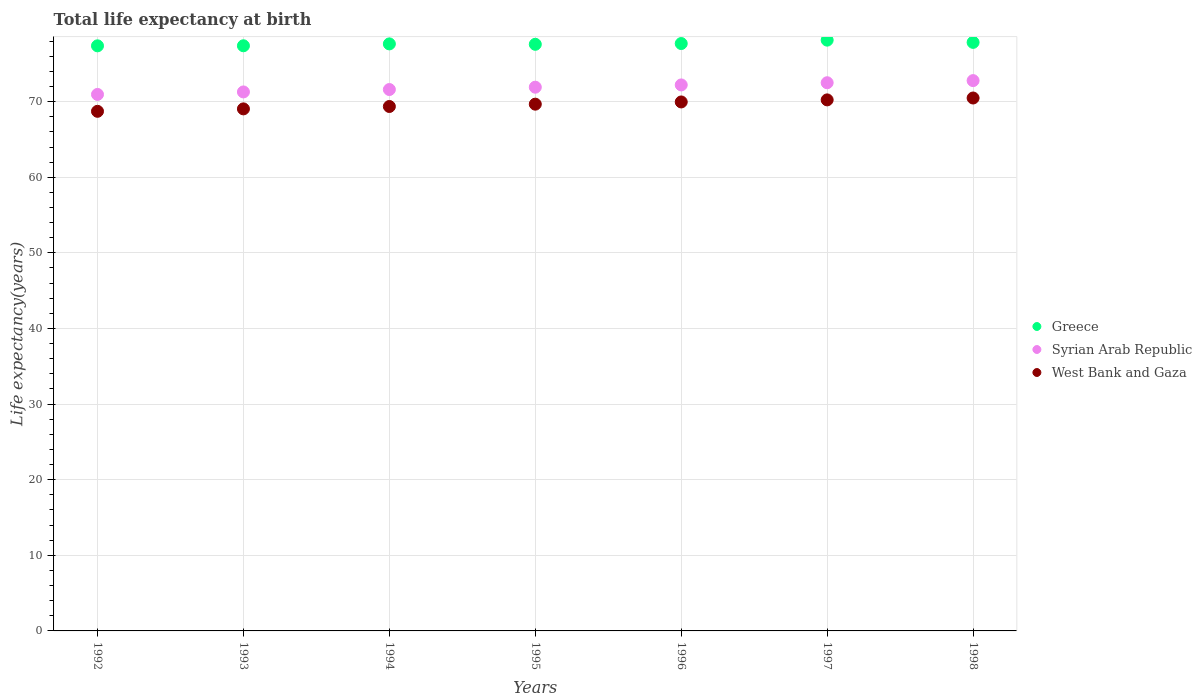How many different coloured dotlines are there?
Ensure brevity in your answer.  3. What is the life expectancy at birth in in West Bank and Gaza in 1993?
Your answer should be compact. 69.04. Across all years, what is the maximum life expectancy at birth in in West Bank and Gaza?
Your response must be concise. 70.48. Across all years, what is the minimum life expectancy at birth in in West Bank and Gaza?
Ensure brevity in your answer.  68.72. What is the total life expectancy at birth in in Syrian Arab Republic in the graph?
Provide a succinct answer. 503.25. What is the difference between the life expectancy at birth in in West Bank and Gaza in 1992 and that in 1993?
Keep it short and to the point. -0.32. What is the difference between the life expectancy at birth in in West Bank and Gaza in 1994 and the life expectancy at birth in in Syrian Arab Republic in 1997?
Your answer should be very brief. -3.14. What is the average life expectancy at birth in in West Bank and Gaza per year?
Offer a terse response. 69.64. In the year 1997, what is the difference between the life expectancy at birth in in West Bank and Gaza and life expectancy at birth in in Syrian Arab Republic?
Ensure brevity in your answer.  -2.27. In how many years, is the life expectancy at birth in in Greece greater than 20 years?
Your response must be concise. 7. What is the ratio of the life expectancy at birth in in Syrian Arab Republic in 1996 to that in 1997?
Provide a short and direct response. 1. What is the difference between the highest and the second highest life expectancy at birth in in Syrian Arab Republic?
Offer a terse response. 0.28. What is the difference between the highest and the lowest life expectancy at birth in in Greece?
Your answer should be very brief. 0.75. In how many years, is the life expectancy at birth in in West Bank and Gaza greater than the average life expectancy at birth in in West Bank and Gaza taken over all years?
Your answer should be very brief. 4. Does the life expectancy at birth in in Syrian Arab Republic monotonically increase over the years?
Keep it short and to the point. Yes. Is the life expectancy at birth in in Greece strictly greater than the life expectancy at birth in in Syrian Arab Republic over the years?
Provide a short and direct response. Yes. How many dotlines are there?
Your response must be concise. 3. Does the graph contain any zero values?
Offer a terse response. No. Does the graph contain grids?
Ensure brevity in your answer.  Yes. How many legend labels are there?
Provide a short and direct response. 3. What is the title of the graph?
Keep it short and to the point. Total life expectancy at birth. Does "Mozambique" appear as one of the legend labels in the graph?
Offer a very short reply. No. What is the label or title of the X-axis?
Offer a very short reply. Years. What is the label or title of the Y-axis?
Keep it short and to the point. Life expectancy(years). What is the Life expectancy(years) of Greece in 1992?
Your answer should be compact. 77.38. What is the Life expectancy(years) in Syrian Arab Republic in 1992?
Give a very brief answer. 70.96. What is the Life expectancy(years) in West Bank and Gaza in 1992?
Your response must be concise. 68.72. What is the Life expectancy(years) in Greece in 1993?
Keep it short and to the point. 77.39. What is the Life expectancy(years) in Syrian Arab Republic in 1993?
Your answer should be very brief. 71.29. What is the Life expectancy(years) in West Bank and Gaza in 1993?
Give a very brief answer. 69.04. What is the Life expectancy(years) of Greece in 1994?
Offer a terse response. 77.64. What is the Life expectancy(years) of Syrian Arab Republic in 1994?
Your response must be concise. 71.6. What is the Life expectancy(years) of West Bank and Gaza in 1994?
Offer a terse response. 69.36. What is the Life expectancy(years) in Greece in 1995?
Your answer should be very brief. 77.59. What is the Life expectancy(years) in Syrian Arab Republic in 1995?
Make the answer very short. 71.91. What is the Life expectancy(years) of West Bank and Gaza in 1995?
Give a very brief answer. 69.67. What is the Life expectancy(years) in Greece in 1996?
Your response must be concise. 77.69. What is the Life expectancy(years) in Syrian Arab Republic in 1996?
Give a very brief answer. 72.21. What is the Life expectancy(years) of West Bank and Gaza in 1996?
Your response must be concise. 69.96. What is the Life expectancy(years) of Greece in 1997?
Ensure brevity in your answer.  78.14. What is the Life expectancy(years) of Syrian Arab Republic in 1997?
Your answer should be compact. 72.5. What is the Life expectancy(years) of West Bank and Gaza in 1997?
Provide a succinct answer. 70.23. What is the Life expectancy(years) of Greece in 1998?
Your answer should be very brief. 77.84. What is the Life expectancy(years) in Syrian Arab Republic in 1998?
Your response must be concise. 72.78. What is the Life expectancy(years) of West Bank and Gaza in 1998?
Your response must be concise. 70.48. Across all years, what is the maximum Life expectancy(years) of Greece?
Your response must be concise. 78.14. Across all years, what is the maximum Life expectancy(years) of Syrian Arab Republic?
Provide a short and direct response. 72.78. Across all years, what is the maximum Life expectancy(years) of West Bank and Gaza?
Your answer should be compact. 70.48. Across all years, what is the minimum Life expectancy(years) in Greece?
Your response must be concise. 77.38. Across all years, what is the minimum Life expectancy(years) of Syrian Arab Republic?
Keep it short and to the point. 70.96. Across all years, what is the minimum Life expectancy(years) of West Bank and Gaza?
Your response must be concise. 68.72. What is the total Life expectancy(years) in Greece in the graph?
Ensure brevity in your answer.  543.66. What is the total Life expectancy(years) of Syrian Arab Republic in the graph?
Make the answer very short. 503.25. What is the total Life expectancy(years) of West Bank and Gaza in the graph?
Your answer should be very brief. 487.47. What is the difference between the Life expectancy(years) in Greece in 1992 and that in 1993?
Ensure brevity in your answer.  -0.01. What is the difference between the Life expectancy(years) of Syrian Arab Republic in 1992 and that in 1993?
Make the answer very short. -0.33. What is the difference between the Life expectancy(years) in West Bank and Gaza in 1992 and that in 1993?
Give a very brief answer. -0.32. What is the difference between the Life expectancy(years) in Greece in 1992 and that in 1994?
Keep it short and to the point. -0.26. What is the difference between the Life expectancy(years) of Syrian Arab Republic in 1992 and that in 1994?
Your response must be concise. -0.65. What is the difference between the Life expectancy(years) of West Bank and Gaza in 1992 and that in 1994?
Offer a very short reply. -0.64. What is the difference between the Life expectancy(years) in Greece in 1992 and that in 1995?
Ensure brevity in your answer.  -0.2. What is the difference between the Life expectancy(years) of Syrian Arab Republic in 1992 and that in 1995?
Give a very brief answer. -0.96. What is the difference between the Life expectancy(years) in West Bank and Gaza in 1992 and that in 1995?
Make the answer very short. -0.94. What is the difference between the Life expectancy(years) in Greece in 1992 and that in 1996?
Your response must be concise. -0.3. What is the difference between the Life expectancy(years) in Syrian Arab Republic in 1992 and that in 1996?
Your answer should be very brief. -1.26. What is the difference between the Life expectancy(years) in West Bank and Gaza in 1992 and that in 1996?
Offer a terse response. -1.24. What is the difference between the Life expectancy(years) in Greece in 1992 and that in 1997?
Keep it short and to the point. -0.75. What is the difference between the Life expectancy(years) in Syrian Arab Republic in 1992 and that in 1997?
Offer a terse response. -1.55. What is the difference between the Life expectancy(years) of West Bank and Gaza in 1992 and that in 1997?
Offer a terse response. -1.51. What is the difference between the Life expectancy(years) in Greece in 1992 and that in 1998?
Provide a short and direct response. -0.46. What is the difference between the Life expectancy(years) of Syrian Arab Republic in 1992 and that in 1998?
Ensure brevity in your answer.  -1.83. What is the difference between the Life expectancy(years) in West Bank and Gaza in 1992 and that in 1998?
Provide a succinct answer. -1.76. What is the difference between the Life expectancy(years) of Greece in 1993 and that in 1994?
Provide a short and direct response. -0.25. What is the difference between the Life expectancy(years) of Syrian Arab Republic in 1993 and that in 1994?
Ensure brevity in your answer.  -0.32. What is the difference between the Life expectancy(years) of West Bank and Gaza in 1993 and that in 1994?
Provide a succinct answer. -0.32. What is the difference between the Life expectancy(years) in Greece in 1993 and that in 1995?
Provide a short and direct response. -0.2. What is the difference between the Life expectancy(years) of Syrian Arab Republic in 1993 and that in 1995?
Your response must be concise. -0.63. What is the difference between the Life expectancy(years) of West Bank and Gaza in 1993 and that in 1995?
Offer a terse response. -0.62. What is the difference between the Life expectancy(years) of Greece in 1993 and that in 1996?
Your answer should be compact. -0.3. What is the difference between the Life expectancy(years) in Syrian Arab Republic in 1993 and that in 1996?
Keep it short and to the point. -0.93. What is the difference between the Life expectancy(years) of West Bank and Gaza in 1993 and that in 1996?
Make the answer very short. -0.92. What is the difference between the Life expectancy(years) of Greece in 1993 and that in 1997?
Your response must be concise. -0.75. What is the difference between the Life expectancy(years) in Syrian Arab Republic in 1993 and that in 1997?
Offer a terse response. -1.22. What is the difference between the Life expectancy(years) in West Bank and Gaza in 1993 and that in 1997?
Provide a succinct answer. -1.19. What is the difference between the Life expectancy(years) in Greece in 1993 and that in 1998?
Give a very brief answer. -0.45. What is the difference between the Life expectancy(years) in Syrian Arab Republic in 1993 and that in 1998?
Your answer should be compact. -1.5. What is the difference between the Life expectancy(years) of West Bank and Gaza in 1993 and that in 1998?
Offer a very short reply. -1.44. What is the difference between the Life expectancy(years) of Greece in 1994 and that in 1995?
Offer a very short reply. 0.05. What is the difference between the Life expectancy(years) of Syrian Arab Republic in 1994 and that in 1995?
Ensure brevity in your answer.  -0.31. What is the difference between the Life expectancy(years) of West Bank and Gaza in 1994 and that in 1995?
Your answer should be very brief. -0.31. What is the difference between the Life expectancy(years) of Greece in 1994 and that in 1996?
Your answer should be very brief. -0.05. What is the difference between the Life expectancy(years) in Syrian Arab Republic in 1994 and that in 1996?
Provide a short and direct response. -0.61. What is the difference between the Life expectancy(years) in West Bank and Gaza in 1994 and that in 1996?
Keep it short and to the point. -0.6. What is the difference between the Life expectancy(years) in Greece in 1994 and that in 1997?
Offer a terse response. -0.5. What is the difference between the Life expectancy(years) in Syrian Arab Republic in 1994 and that in 1997?
Offer a very short reply. -0.9. What is the difference between the Life expectancy(years) in West Bank and Gaza in 1994 and that in 1997?
Offer a terse response. -0.87. What is the difference between the Life expectancy(years) of Syrian Arab Republic in 1994 and that in 1998?
Offer a very short reply. -1.18. What is the difference between the Life expectancy(years) of West Bank and Gaza in 1994 and that in 1998?
Ensure brevity in your answer.  -1.12. What is the difference between the Life expectancy(years) of Syrian Arab Republic in 1995 and that in 1996?
Offer a very short reply. -0.3. What is the difference between the Life expectancy(years) of West Bank and Gaza in 1995 and that in 1996?
Your answer should be very brief. -0.29. What is the difference between the Life expectancy(years) of Greece in 1995 and that in 1997?
Offer a very short reply. -0.55. What is the difference between the Life expectancy(years) of Syrian Arab Republic in 1995 and that in 1997?
Ensure brevity in your answer.  -0.59. What is the difference between the Life expectancy(years) in West Bank and Gaza in 1995 and that in 1997?
Your answer should be very brief. -0.57. What is the difference between the Life expectancy(years) in Greece in 1995 and that in 1998?
Keep it short and to the point. -0.25. What is the difference between the Life expectancy(years) of Syrian Arab Republic in 1995 and that in 1998?
Your answer should be very brief. -0.87. What is the difference between the Life expectancy(years) of West Bank and Gaza in 1995 and that in 1998?
Your answer should be compact. -0.81. What is the difference between the Life expectancy(years) of Greece in 1996 and that in 1997?
Keep it short and to the point. -0.45. What is the difference between the Life expectancy(years) in Syrian Arab Republic in 1996 and that in 1997?
Make the answer very short. -0.29. What is the difference between the Life expectancy(years) of West Bank and Gaza in 1996 and that in 1997?
Offer a terse response. -0.27. What is the difference between the Life expectancy(years) of Greece in 1996 and that in 1998?
Keep it short and to the point. -0.15. What is the difference between the Life expectancy(years) in Syrian Arab Republic in 1996 and that in 1998?
Your response must be concise. -0.57. What is the difference between the Life expectancy(years) of West Bank and Gaza in 1996 and that in 1998?
Offer a very short reply. -0.52. What is the difference between the Life expectancy(years) in Greece in 1997 and that in 1998?
Your response must be concise. 0.3. What is the difference between the Life expectancy(years) in Syrian Arab Republic in 1997 and that in 1998?
Provide a short and direct response. -0.28. What is the difference between the Life expectancy(years) of West Bank and Gaza in 1997 and that in 1998?
Ensure brevity in your answer.  -0.25. What is the difference between the Life expectancy(years) in Greece in 1992 and the Life expectancy(years) in Syrian Arab Republic in 1993?
Offer a terse response. 6.1. What is the difference between the Life expectancy(years) of Greece in 1992 and the Life expectancy(years) of West Bank and Gaza in 1993?
Offer a very short reply. 8.34. What is the difference between the Life expectancy(years) of Syrian Arab Republic in 1992 and the Life expectancy(years) of West Bank and Gaza in 1993?
Provide a succinct answer. 1.91. What is the difference between the Life expectancy(years) in Greece in 1992 and the Life expectancy(years) in Syrian Arab Republic in 1994?
Your response must be concise. 5.78. What is the difference between the Life expectancy(years) of Greece in 1992 and the Life expectancy(years) of West Bank and Gaza in 1994?
Offer a very short reply. 8.02. What is the difference between the Life expectancy(years) of Syrian Arab Republic in 1992 and the Life expectancy(years) of West Bank and Gaza in 1994?
Make the answer very short. 1.59. What is the difference between the Life expectancy(years) of Greece in 1992 and the Life expectancy(years) of Syrian Arab Republic in 1995?
Provide a succinct answer. 5.47. What is the difference between the Life expectancy(years) in Greece in 1992 and the Life expectancy(years) in West Bank and Gaza in 1995?
Your answer should be compact. 7.72. What is the difference between the Life expectancy(years) of Syrian Arab Republic in 1992 and the Life expectancy(years) of West Bank and Gaza in 1995?
Your response must be concise. 1.29. What is the difference between the Life expectancy(years) in Greece in 1992 and the Life expectancy(years) in Syrian Arab Republic in 1996?
Offer a terse response. 5.17. What is the difference between the Life expectancy(years) of Greece in 1992 and the Life expectancy(years) of West Bank and Gaza in 1996?
Offer a terse response. 7.42. What is the difference between the Life expectancy(years) of Syrian Arab Republic in 1992 and the Life expectancy(years) of West Bank and Gaza in 1996?
Your response must be concise. 0.99. What is the difference between the Life expectancy(years) of Greece in 1992 and the Life expectancy(years) of Syrian Arab Republic in 1997?
Offer a very short reply. 4.88. What is the difference between the Life expectancy(years) in Greece in 1992 and the Life expectancy(years) in West Bank and Gaza in 1997?
Provide a succinct answer. 7.15. What is the difference between the Life expectancy(years) in Syrian Arab Republic in 1992 and the Life expectancy(years) in West Bank and Gaza in 1997?
Your response must be concise. 0.72. What is the difference between the Life expectancy(years) in Greece in 1992 and the Life expectancy(years) in Syrian Arab Republic in 1998?
Your answer should be very brief. 4.6. What is the difference between the Life expectancy(years) of Greece in 1992 and the Life expectancy(years) of West Bank and Gaza in 1998?
Your answer should be very brief. 6.9. What is the difference between the Life expectancy(years) in Syrian Arab Republic in 1992 and the Life expectancy(years) in West Bank and Gaza in 1998?
Ensure brevity in your answer.  0.47. What is the difference between the Life expectancy(years) of Greece in 1993 and the Life expectancy(years) of Syrian Arab Republic in 1994?
Make the answer very short. 5.79. What is the difference between the Life expectancy(years) in Greece in 1993 and the Life expectancy(years) in West Bank and Gaza in 1994?
Give a very brief answer. 8.03. What is the difference between the Life expectancy(years) in Syrian Arab Republic in 1993 and the Life expectancy(years) in West Bank and Gaza in 1994?
Provide a succinct answer. 1.92. What is the difference between the Life expectancy(years) of Greece in 1993 and the Life expectancy(years) of Syrian Arab Republic in 1995?
Offer a very short reply. 5.48. What is the difference between the Life expectancy(years) of Greece in 1993 and the Life expectancy(years) of West Bank and Gaza in 1995?
Your answer should be compact. 7.72. What is the difference between the Life expectancy(years) in Syrian Arab Republic in 1993 and the Life expectancy(years) in West Bank and Gaza in 1995?
Provide a succinct answer. 1.62. What is the difference between the Life expectancy(years) of Greece in 1993 and the Life expectancy(years) of Syrian Arab Republic in 1996?
Ensure brevity in your answer.  5.18. What is the difference between the Life expectancy(years) in Greece in 1993 and the Life expectancy(years) in West Bank and Gaza in 1996?
Provide a succinct answer. 7.43. What is the difference between the Life expectancy(years) of Syrian Arab Republic in 1993 and the Life expectancy(years) of West Bank and Gaza in 1996?
Offer a terse response. 1.32. What is the difference between the Life expectancy(years) in Greece in 1993 and the Life expectancy(years) in Syrian Arab Republic in 1997?
Provide a succinct answer. 4.89. What is the difference between the Life expectancy(years) of Greece in 1993 and the Life expectancy(years) of West Bank and Gaza in 1997?
Keep it short and to the point. 7.16. What is the difference between the Life expectancy(years) in Syrian Arab Republic in 1993 and the Life expectancy(years) in West Bank and Gaza in 1997?
Give a very brief answer. 1.05. What is the difference between the Life expectancy(years) in Greece in 1993 and the Life expectancy(years) in Syrian Arab Republic in 1998?
Your response must be concise. 4.61. What is the difference between the Life expectancy(years) of Greece in 1993 and the Life expectancy(years) of West Bank and Gaza in 1998?
Your response must be concise. 6.91. What is the difference between the Life expectancy(years) of Syrian Arab Republic in 1993 and the Life expectancy(years) of West Bank and Gaza in 1998?
Provide a succinct answer. 0.8. What is the difference between the Life expectancy(years) in Greece in 1994 and the Life expectancy(years) in Syrian Arab Republic in 1995?
Offer a very short reply. 5.73. What is the difference between the Life expectancy(years) of Greece in 1994 and the Life expectancy(years) of West Bank and Gaza in 1995?
Provide a succinct answer. 7.97. What is the difference between the Life expectancy(years) in Syrian Arab Republic in 1994 and the Life expectancy(years) in West Bank and Gaza in 1995?
Provide a short and direct response. 1.94. What is the difference between the Life expectancy(years) of Greece in 1994 and the Life expectancy(years) of Syrian Arab Republic in 1996?
Keep it short and to the point. 5.43. What is the difference between the Life expectancy(years) in Greece in 1994 and the Life expectancy(years) in West Bank and Gaza in 1996?
Provide a succinct answer. 7.68. What is the difference between the Life expectancy(years) in Syrian Arab Republic in 1994 and the Life expectancy(years) in West Bank and Gaza in 1996?
Provide a short and direct response. 1.64. What is the difference between the Life expectancy(years) in Greece in 1994 and the Life expectancy(years) in Syrian Arab Republic in 1997?
Offer a terse response. 5.14. What is the difference between the Life expectancy(years) in Greece in 1994 and the Life expectancy(years) in West Bank and Gaza in 1997?
Your answer should be very brief. 7.41. What is the difference between the Life expectancy(years) of Syrian Arab Republic in 1994 and the Life expectancy(years) of West Bank and Gaza in 1997?
Your answer should be compact. 1.37. What is the difference between the Life expectancy(years) in Greece in 1994 and the Life expectancy(years) in Syrian Arab Republic in 1998?
Provide a succinct answer. 4.86. What is the difference between the Life expectancy(years) of Greece in 1994 and the Life expectancy(years) of West Bank and Gaza in 1998?
Make the answer very short. 7.16. What is the difference between the Life expectancy(years) in Syrian Arab Republic in 1994 and the Life expectancy(years) in West Bank and Gaza in 1998?
Offer a terse response. 1.12. What is the difference between the Life expectancy(years) in Greece in 1995 and the Life expectancy(years) in Syrian Arab Republic in 1996?
Keep it short and to the point. 5.37. What is the difference between the Life expectancy(years) in Greece in 1995 and the Life expectancy(years) in West Bank and Gaza in 1996?
Ensure brevity in your answer.  7.62. What is the difference between the Life expectancy(years) of Syrian Arab Republic in 1995 and the Life expectancy(years) of West Bank and Gaza in 1996?
Your answer should be compact. 1.95. What is the difference between the Life expectancy(years) of Greece in 1995 and the Life expectancy(years) of Syrian Arab Republic in 1997?
Your response must be concise. 5.08. What is the difference between the Life expectancy(years) of Greece in 1995 and the Life expectancy(years) of West Bank and Gaza in 1997?
Ensure brevity in your answer.  7.35. What is the difference between the Life expectancy(years) of Syrian Arab Republic in 1995 and the Life expectancy(years) of West Bank and Gaza in 1997?
Your answer should be very brief. 1.68. What is the difference between the Life expectancy(years) of Greece in 1995 and the Life expectancy(years) of Syrian Arab Republic in 1998?
Your response must be concise. 4.8. What is the difference between the Life expectancy(years) in Greece in 1995 and the Life expectancy(years) in West Bank and Gaza in 1998?
Make the answer very short. 7.1. What is the difference between the Life expectancy(years) of Syrian Arab Republic in 1995 and the Life expectancy(years) of West Bank and Gaza in 1998?
Keep it short and to the point. 1.43. What is the difference between the Life expectancy(years) in Greece in 1996 and the Life expectancy(years) in Syrian Arab Republic in 1997?
Offer a very short reply. 5.18. What is the difference between the Life expectancy(years) of Greece in 1996 and the Life expectancy(years) of West Bank and Gaza in 1997?
Your answer should be compact. 7.45. What is the difference between the Life expectancy(years) of Syrian Arab Republic in 1996 and the Life expectancy(years) of West Bank and Gaza in 1997?
Your answer should be compact. 1.98. What is the difference between the Life expectancy(years) in Greece in 1996 and the Life expectancy(years) in Syrian Arab Republic in 1998?
Offer a very short reply. 4.9. What is the difference between the Life expectancy(years) in Greece in 1996 and the Life expectancy(years) in West Bank and Gaza in 1998?
Offer a terse response. 7.2. What is the difference between the Life expectancy(years) of Syrian Arab Republic in 1996 and the Life expectancy(years) of West Bank and Gaza in 1998?
Give a very brief answer. 1.73. What is the difference between the Life expectancy(years) in Greece in 1997 and the Life expectancy(years) in Syrian Arab Republic in 1998?
Your answer should be very brief. 5.35. What is the difference between the Life expectancy(years) of Greece in 1997 and the Life expectancy(years) of West Bank and Gaza in 1998?
Your answer should be compact. 7.65. What is the difference between the Life expectancy(years) of Syrian Arab Republic in 1997 and the Life expectancy(years) of West Bank and Gaza in 1998?
Offer a very short reply. 2.02. What is the average Life expectancy(years) in Greece per year?
Offer a very short reply. 77.67. What is the average Life expectancy(years) of Syrian Arab Republic per year?
Your response must be concise. 71.89. What is the average Life expectancy(years) in West Bank and Gaza per year?
Give a very brief answer. 69.64. In the year 1992, what is the difference between the Life expectancy(years) in Greece and Life expectancy(years) in Syrian Arab Republic?
Your answer should be compact. 6.43. In the year 1992, what is the difference between the Life expectancy(years) in Greece and Life expectancy(years) in West Bank and Gaza?
Give a very brief answer. 8.66. In the year 1992, what is the difference between the Life expectancy(years) in Syrian Arab Republic and Life expectancy(years) in West Bank and Gaza?
Ensure brevity in your answer.  2.23. In the year 1993, what is the difference between the Life expectancy(years) of Greece and Life expectancy(years) of Syrian Arab Republic?
Provide a succinct answer. 6.11. In the year 1993, what is the difference between the Life expectancy(years) of Greece and Life expectancy(years) of West Bank and Gaza?
Provide a short and direct response. 8.35. In the year 1993, what is the difference between the Life expectancy(years) of Syrian Arab Republic and Life expectancy(years) of West Bank and Gaza?
Offer a terse response. 2.24. In the year 1994, what is the difference between the Life expectancy(years) of Greece and Life expectancy(years) of Syrian Arab Republic?
Offer a terse response. 6.04. In the year 1994, what is the difference between the Life expectancy(years) in Greece and Life expectancy(years) in West Bank and Gaza?
Make the answer very short. 8.28. In the year 1994, what is the difference between the Life expectancy(years) in Syrian Arab Republic and Life expectancy(years) in West Bank and Gaza?
Make the answer very short. 2.24. In the year 1995, what is the difference between the Life expectancy(years) in Greece and Life expectancy(years) in Syrian Arab Republic?
Give a very brief answer. 5.67. In the year 1995, what is the difference between the Life expectancy(years) of Greece and Life expectancy(years) of West Bank and Gaza?
Your answer should be compact. 7.92. In the year 1995, what is the difference between the Life expectancy(years) of Syrian Arab Republic and Life expectancy(years) of West Bank and Gaza?
Make the answer very short. 2.25. In the year 1996, what is the difference between the Life expectancy(years) in Greece and Life expectancy(years) in Syrian Arab Republic?
Give a very brief answer. 5.47. In the year 1996, what is the difference between the Life expectancy(years) in Greece and Life expectancy(years) in West Bank and Gaza?
Offer a terse response. 7.72. In the year 1996, what is the difference between the Life expectancy(years) of Syrian Arab Republic and Life expectancy(years) of West Bank and Gaza?
Your answer should be very brief. 2.25. In the year 1997, what is the difference between the Life expectancy(years) of Greece and Life expectancy(years) of Syrian Arab Republic?
Offer a terse response. 5.63. In the year 1997, what is the difference between the Life expectancy(years) of Greece and Life expectancy(years) of West Bank and Gaza?
Give a very brief answer. 7.9. In the year 1997, what is the difference between the Life expectancy(years) of Syrian Arab Republic and Life expectancy(years) of West Bank and Gaza?
Make the answer very short. 2.27. In the year 1998, what is the difference between the Life expectancy(years) of Greece and Life expectancy(years) of Syrian Arab Republic?
Make the answer very short. 5.06. In the year 1998, what is the difference between the Life expectancy(years) of Greece and Life expectancy(years) of West Bank and Gaza?
Offer a very short reply. 7.36. In the year 1998, what is the difference between the Life expectancy(years) of Syrian Arab Republic and Life expectancy(years) of West Bank and Gaza?
Offer a very short reply. 2.3. What is the ratio of the Life expectancy(years) of West Bank and Gaza in 1992 to that in 1993?
Ensure brevity in your answer.  1. What is the ratio of the Life expectancy(years) in Greece in 1992 to that in 1994?
Make the answer very short. 1. What is the ratio of the Life expectancy(years) in Syrian Arab Republic in 1992 to that in 1994?
Provide a short and direct response. 0.99. What is the ratio of the Life expectancy(years) of West Bank and Gaza in 1992 to that in 1994?
Give a very brief answer. 0.99. What is the ratio of the Life expectancy(years) in Syrian Arab Republic in 1992 to that in 1995?
Your response must be concise. 0.99. What is the ratio of the Life expectancy(years) in West Bank and Gaza in 1992 to that in 1995?
Give a very brief answer. 0.99. What is the ratio of the Life expectancy(years) in Greece in 1992 to that in 1996?
Your response must be concise. 1. What is the ratio of the Life expectancy(years) of Syrian Arab Republic in 1992 to that in 1996?
Offer a very short reply. 0.98. What is the ratio of the Life expectancy(years) in West Bank and Gaza in 1992 to that in 1996?
Give a very brief answer. 0.98. What is the ratio of the Life expectancy(years) of Syrian Arab Republic in 1992 to that in 1997?
Provide a succinct answer. 0.98. What is the ratio of the Life expectancy(years) of West Bank and Gaza in 1992 to that in 1997?
Provide a succinct answer. 0.98. What is the ratio of the Life expectancy(years) in Syrian Arab Republic in 1992 to that in 1998?
Your answer should be compact. 0.97. What is the ratio of the Life expectancy(years) of West Bank and Gaza in 1992 to that in 1998?
Your response must be concise. 0.97. What is the ratio of the Life expectancy(years) in Greece in 1993 to that in 1994?
Keep it short and to the point. 1. What is the ratio of the Life expectancy(years) of Syrian Arab Republic in 1993 to that in 1995?
Keep it short and to the point. 0.99. What is the ratio of the Life expectancy(years) of Greece in 1993 to that in 1996?
Keep it short and to the point. 1. What is the ratio of the Life expectancy(years) in Syrian Arab Republic in 1993 to that in 1996?
Provide a short and direct response. 0.99. What is the ratio of the Life expectancy(years) of West Bank and Gaza in 1993 to that in 1996?
Give a very brief answer. 0.99. What is the ratio of the Life expectancy(years) in Greece in 1993 to that in 1997?
Your answer should be compact. 0.99. What is the ratio of the Life expectancy(years) of Syrian Arab Republic in 1993 to that in 1997?
Ensure brevity in your answer.  0.98. What is the ratio of the Life expectancy(years) of West Bank and Gaza in 1993 to that in 1997?
Keep it short and to the point. 0.98. What is the ratio of the Life expectancy(years) in Syrian Arab Republic in 1993 to that in 1998?
Provide a succinct answer. 0.98. What is the ratio of the Life expectancy(years) of West Bank and Gaza in 1993 to that in 1998?
Your answer should be compact. 0.98. What is the ratio of the Life expectancy(years) of Greece in 1994 to that in 1995?
Your response must be concise. 1. What is the ratio of the Life expectancy(years) of Syrian Arab Republic in 1994 to that in 1995?
Keep it short and to the point. 1. What is the ratio of the Life expectancy(years) in West Bank and Gaza in 1994 to that in 1995?
Offer a very short reply. 1. What is the ratio of the Life expectancy(years) in Syrian Arab Republic in 1994 to that in 1996?
Your answer should be compact. 0.99. What is the ratio of the Life expectancy(years) of Greece in 1994 to that in 1997?
Offer a terse response. 0.99. What is the ratio of the Life expectancy(years) of Syrian Arab Republic in 1994 to that in 1997?
Make the answer very short. 0.99. What is the ratio of the Life expectancy(years) in West Bank and Gaza in 1994 to that in 1997?
Your response must be concise. 0.99. What is the ratio of the Life expectancy(years) in Greece in 1994 to that in 1998?
Offer a terse response. 1. What is the ratio of the Life expectancy(years) of Syrian Arab Republic in 1994 to that in 1998?
Provide a short and direct response. 0.98. What is the ratio of the Life expectancy(years) of West Bank and Gaza in 1994 to that in 1998?
Your answer should be compact. 0.98. What is the ratio of the Life expectancy(years) in Syrian Arab Republic in 1995 to that in 1996?
Your answer should be compact. 1. What is the ratio of the Life expectancy(years) in Greece in 1995 to that in 1997?
Your answer should be compact. 0.99. What is the ratio of the Life expectancy(years) of West Bank and Gaza in 1995 to that in 1997?
Ensure brevity in your answer.  0.99. What is the ratio of the Life expectancy(years) of Syrian Arab Republic in 1995 to that in 1998?
Offer a very short reply. 0.99. What is the ratio of the Life expectancy(years) in West Bank and Gaza in 1995 to that in 1998?
Your answer should be compact. 0.99. What is the ratio of the Life expectancy(years) in Greece in 1996 to that in 1997?
Give a very brief answer. 0.99. What is the ratio of the Life expectancy(years) of Syrian Arab Republic in 1996 to that in 1998?
Offer a terse response. 0.99. What is the ratio of the Life expectancy(years) of West Bank and Gaza in 1996 to that in 1998?
Your answer should be very brief. 0.99. What is the ratio of the Life expectancy(years) in Greece in 1997 to that in 1998?
Give a very brief answer. 1. What is the ratio of the Life expectancy(years) of Syrian Arab Republic in 1997 to that in 1998?
Make the answer very short. 1. What is the difference between the highest and the second highest Life expectancy(years) of Greece?
Provide a short and direct response. 0.3. What is the difference between the highest and the second highest Life expectancy(years) of Syrian Arab Republic?
Offer a terse response. 0.28. What is the difference between the highest and the second highest Life expectancy(years) in West Bank and Gaza?
Keep it short and to the point. 0.25. What is the difference between the highest and the lowest Life expectancy(years) in Greece?
Your response must be concise. 0.75. What is the difference between the highest and the lowest Life expectancy(years) in Syrian Arab Republic?
Provide a short and direct response. 1.83. What is the difference between the highest and the lowest Life expectancy(years) in West Bank and Gaza?
Provide a succinct answer. 1.76. 